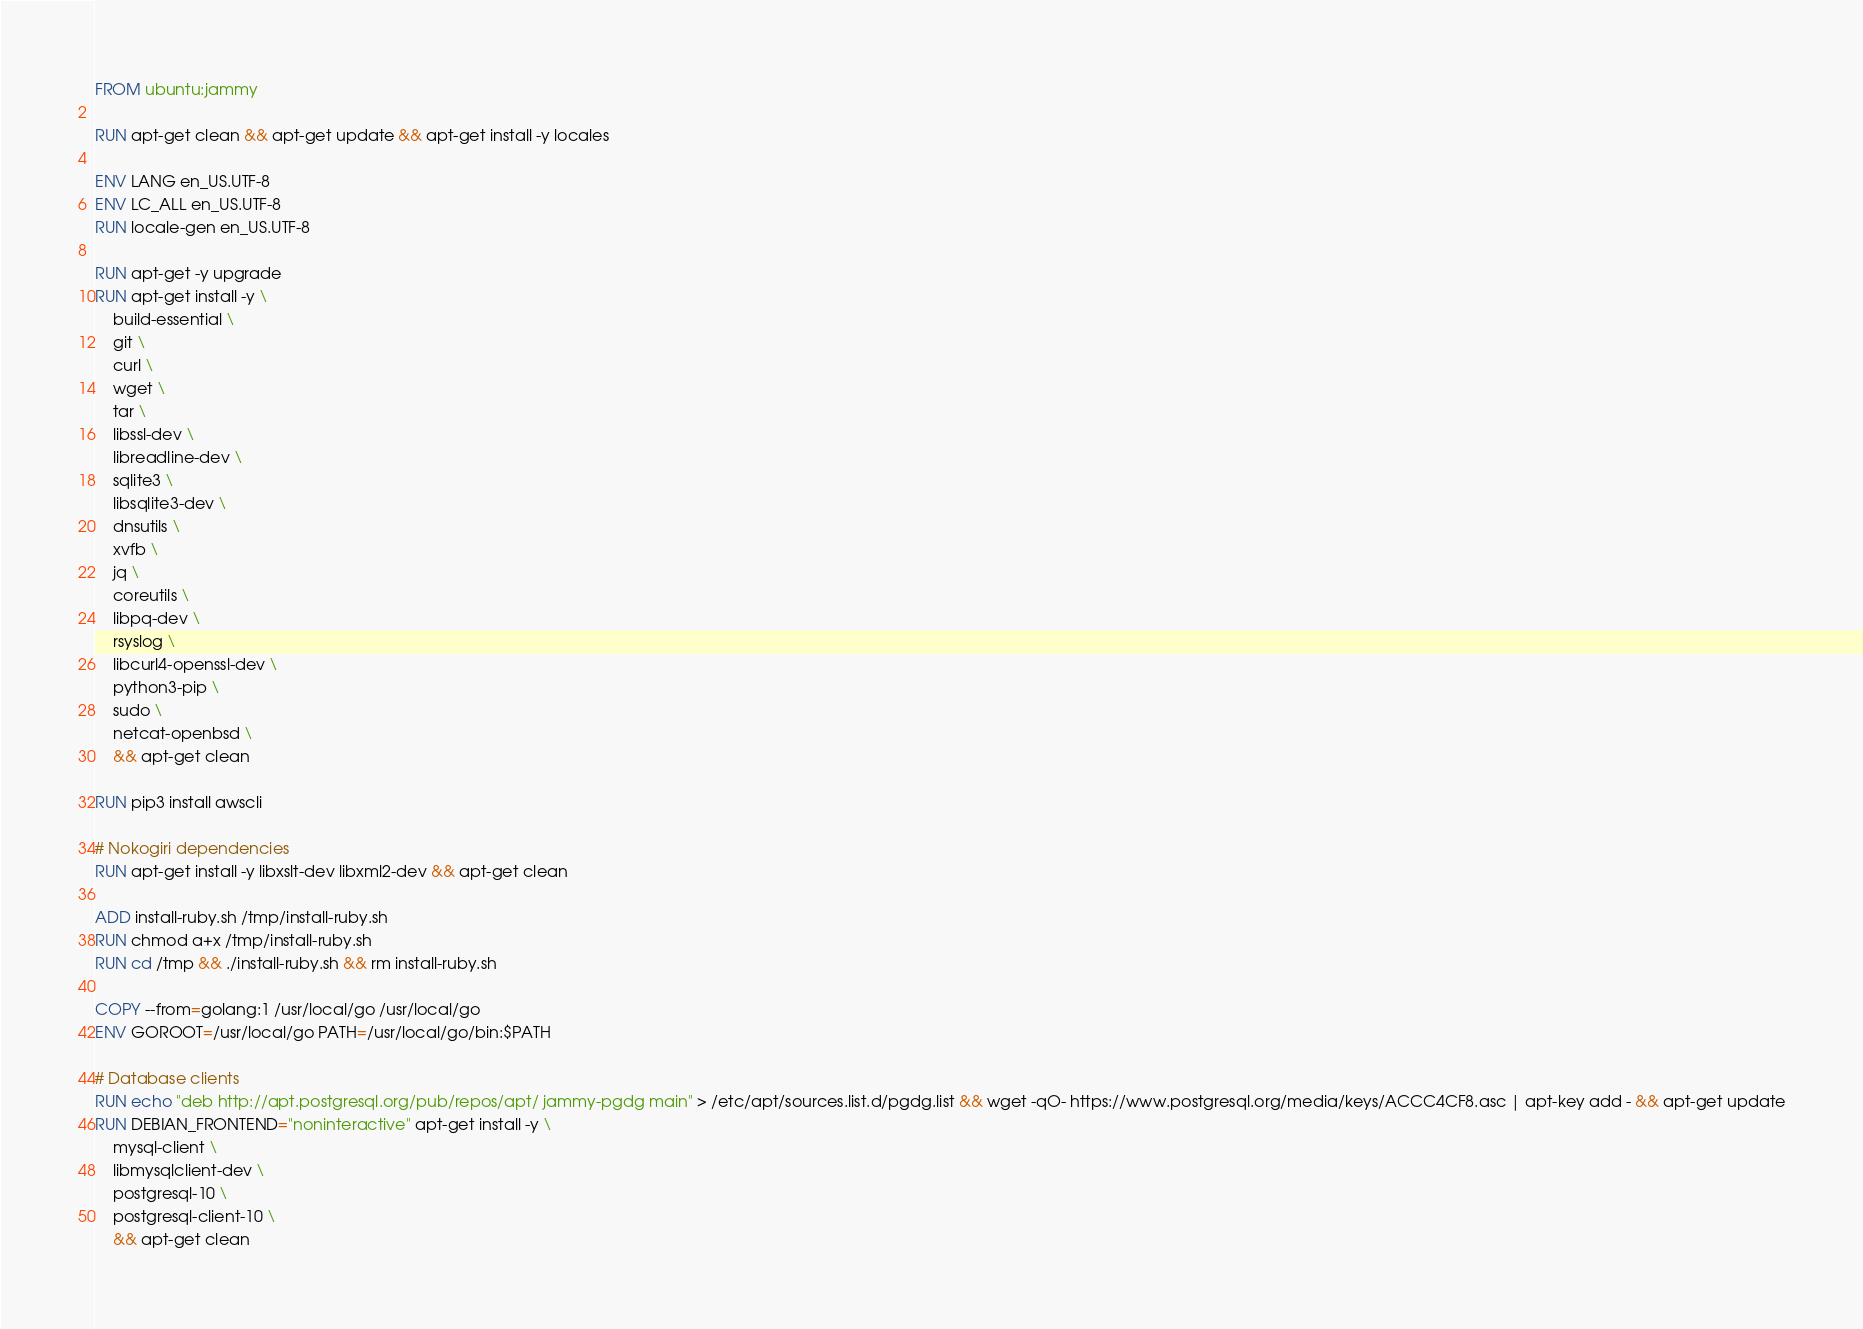Convert code to text. <code><loc_0><loc_0><loc_500><loc_500><_Dockerfile_>FROM ubuntu:jammy

RUN apt-get clean && apt-get update && apt-get install -y locales

ENV LANG en_US.UTF-8
ENV LC_ALL en_US.UTF-8
RUN locale-gen en_US.UTF-8

RUN apt-get -y upgrade
RUN apt-get install -y \
	build-essential \
	git \
	curl \
	wget \
	tar \
	libssl-dev \
	libreadline-dev \
	sqlite3 \
	libsqlite3-dev \
	dnsutils \
	xvfb \
	jq \
	coreutils \
	libpq-dev \
	rsyslog \
	libcurl4-openssl-dev \
	python3-pip \
	sudo \
	netcat-openbsd \
	&& apt-get clean

RUN pip3 install awscli

# Nokogiri dependencies
RUN apt-get install -y libxslt-dev libxml2-dev && apt-get clean

ADD install-ruby.sh /tmp/install-ruby.sh
RUN chmod a+x /tmp/install-ruby.sh
RUN cd /tmp && ./install-ruby.sh && rm install-ruby.sh

COPY --from=golang:1 /usr/local/go /usr/local/go
ENV GOROOT=/usr/local/go PATH=/usr/local/go/bin:$PATH

# Database clients
RUN echo "deb http://apt.postgresql.org/pub/repos/apt/ jammy-pgdg main" > /etc/apt/sources.list.d/pgdg.list && wget -qO- https://www.postgresql.org/media/keys/ACCC4CF8.asc | apt-key add - && apt-get update
RUN DEBIAN_FRONTEND="noninteractive" apt-get install -y \
	mysql-client \
	libmysqlclient-dev \
	postgresql-10 \
	postgresql-client-10 \
	&& apt-get clean
</code> 